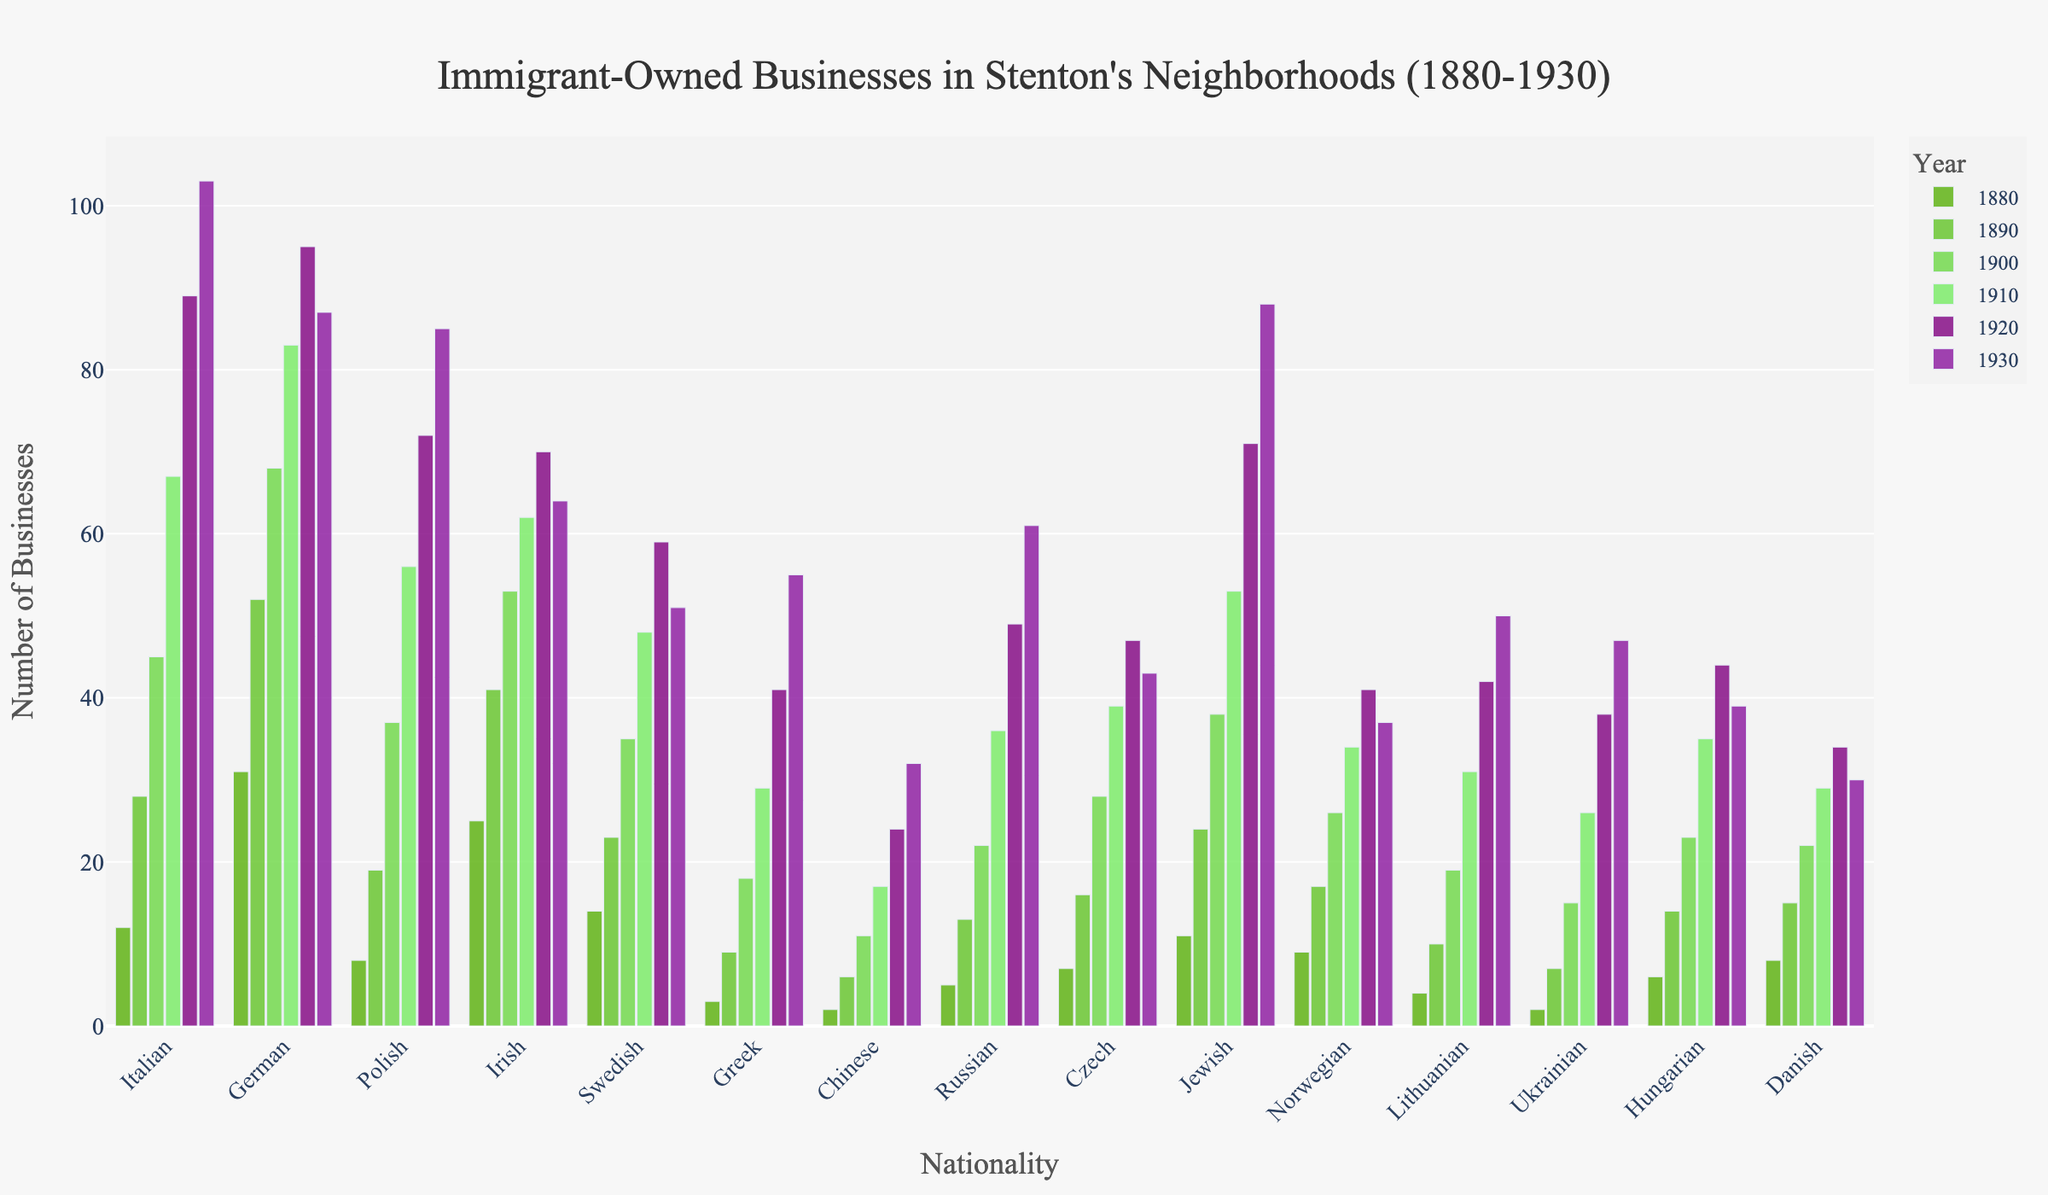Which nationality had the highest number of businesses in 1930? Look at the bars for the year 1930 and identify which one is tallest. The tallest bar represents Italian businesses.
Answer: Italian How did the number of Irish businesses change from 1880 to 1930? Start from the bar for the Irish in 1880 and compare it to the bar for 1930. The number decreased from 25 businesses in 1880 to 64 in 1930.
Answer: Increased from 25 to 64 Which nationalities had more businesses in 1930 compared to 1880? Compare the bars for 1930 and 1880 for each nationality. Categories with a taller bar in 1930 than in 1880 include Italian, Polish, Greek, Chinese, Russian, Jewish, Lithuanian, Ukrainian, Hungarian, and Danish.
Answer: Italian, Polish, Greek, Chinese, Russian, Jewish, Lithuanian, Ukrainian, Hungarian, Danish What is the total number of German businesses in the time period 1880-1930? Add the values for German businesses across all years: 31 + 52 + 68 + 83 + 95 + 87.
Answer: 416 Which nationality saw the greatest relative increase in businesses from 1880 to 1930? Calculate the ratio of businesses in 1930 to those in 1880 for each nationality and find the maximum ratio. The Greek nationality saw the largest increase from 3 to 55, which is more than an 18-fold increase.
Answer: Greek Which two nationalities had approximately the same number of businesses in 1930? Compare the bars for different nationalities in 1930 to find ones with similar heights. Ukrainian (47) and Hungarian (39) are closest.
Answer: Ukrainian and Hungarian What was the average number of Italian businesses per decade from 1880 to 1930? Add the number of Italian businesses for all years and then divide by the number of years: (12 + 28 + 45 + 67 + 89 + 103) / 6.
Answer: 57.3 Which nationality showed a decline in businesses from 1920 to 1930? Compare the bars for 1920 and 1930 for each nationality and see if any bar is shorter in 1930. German (95 to 87) and Swedish (59 to 51) showed declines.
Answer: German and Swedish What is the difference in the number of Polish and Jewish businesses in 1910? Subtract the number of Jewish businesses from Polish businesses in 1910: 56 - 53.
Answer: 3 